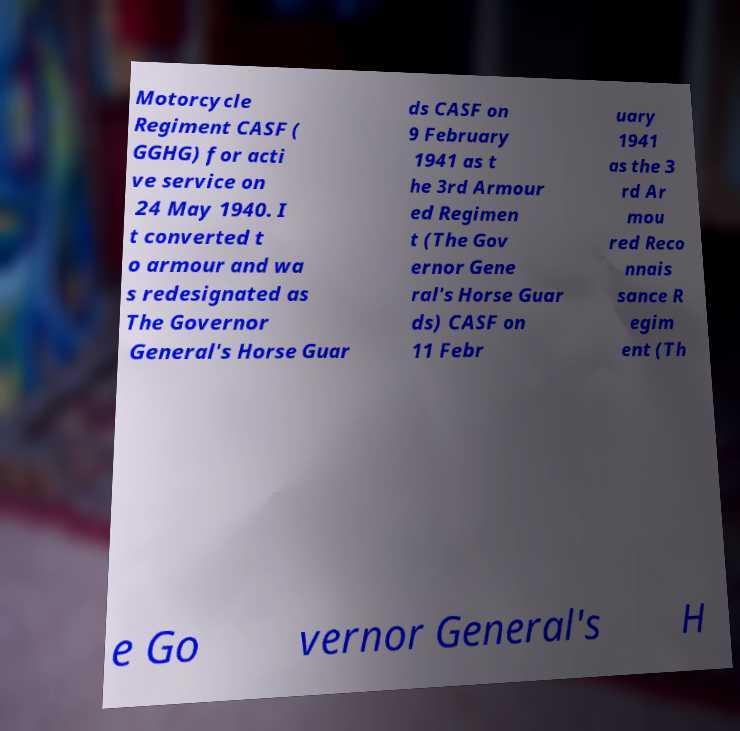There's text embedded in this image that I need extracted. Can you transcribe it verbatim? Motorcycle Regiment CASF ( GGHG) for acti ve service on 24 May 1940. I t converted t o armour and wa s redesignated as The Governor General's Horse Guar ds CASF on 9 February 1941 as t he 3rd Armour ed Regimen t (The Gov ernor Gene ral's Horse Guar ds) CASF on 11 Febr uary 1941 as the 3 rd Ar mou red Reco nnais sance R egim ent (Th e Go vernor General's H 